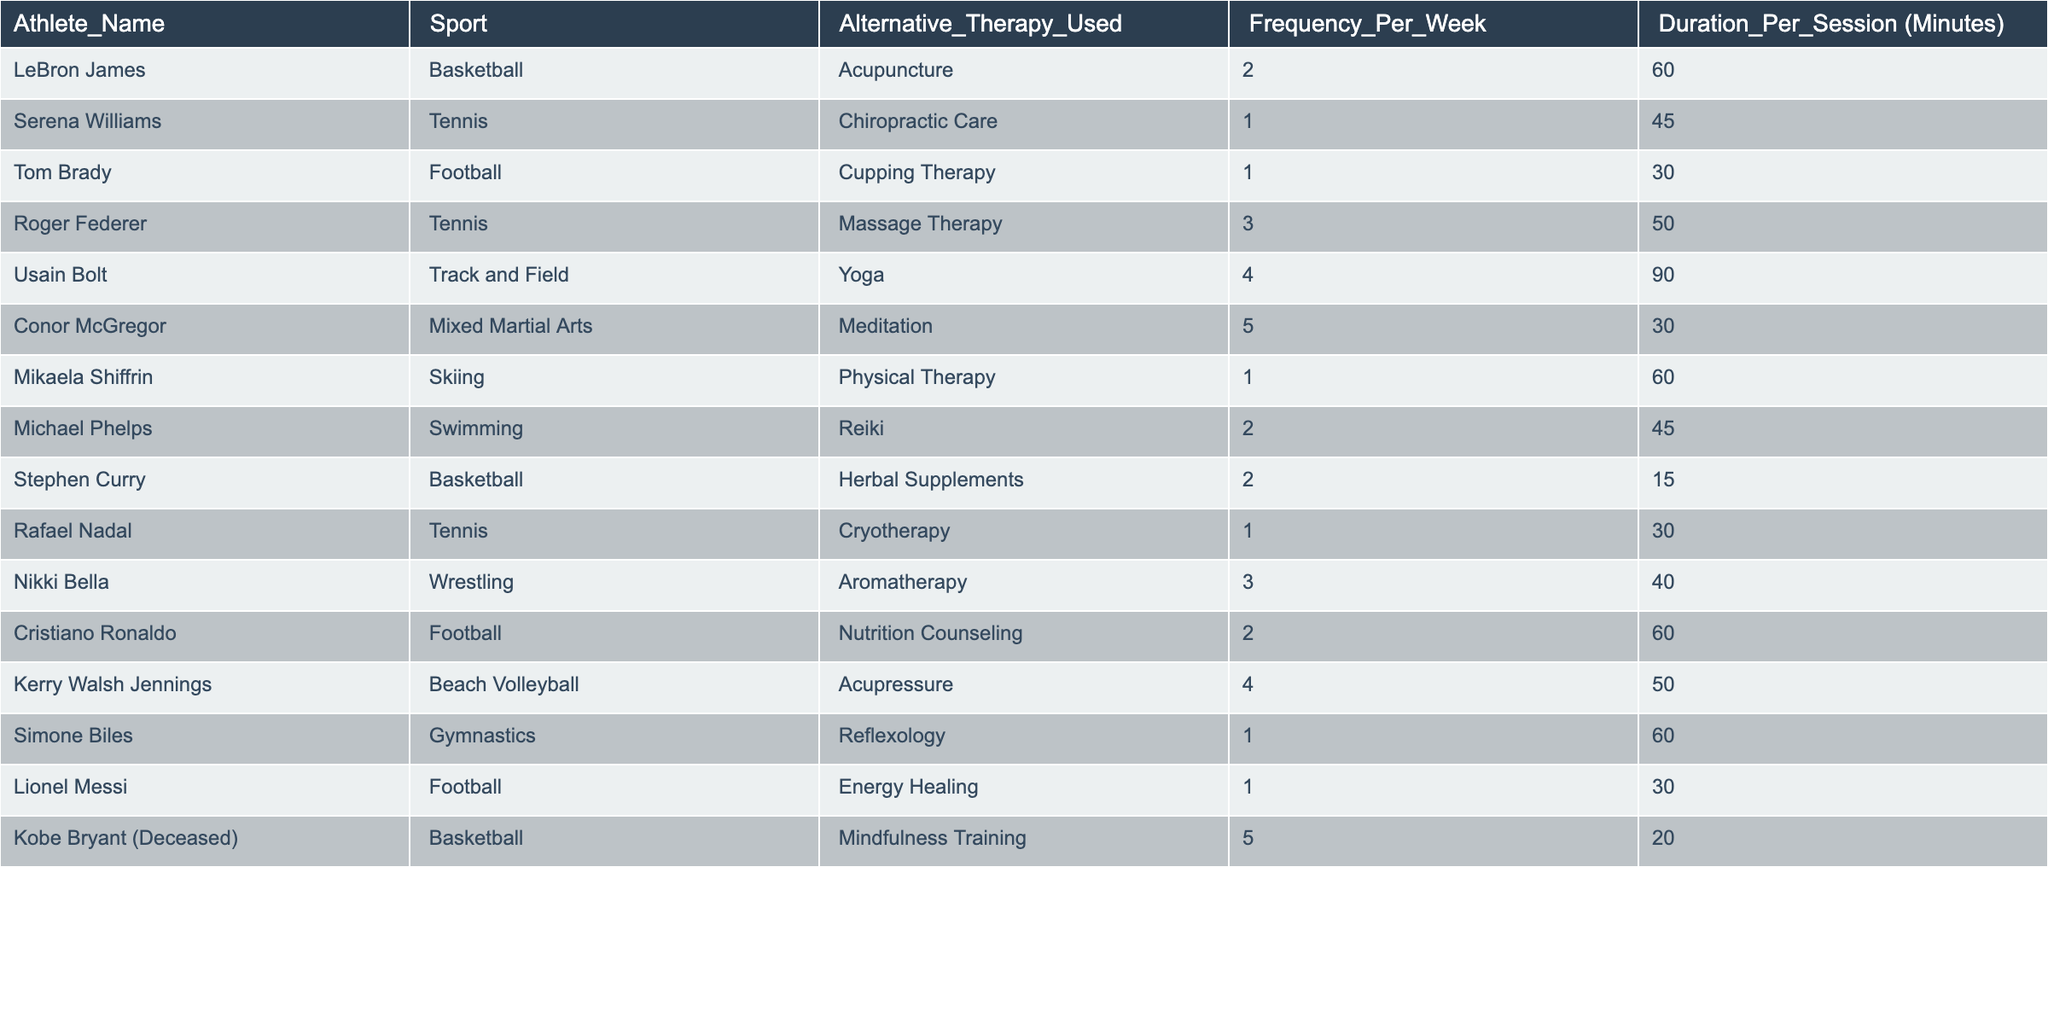What alternative therapy does Usain Bolt use? Referring to the table, Usain Bolt is listed under the "Athlete_Name" column, and the corresponding "Alternative_Therapy_Used" is "Yoga."
Answer: Yoga How many times per week does Conor McGregor practice meditation? Looking at the "Frequency_Per_Week" column for Conor McGregor, it shows he practices meditation 5 times per week.
Answer: 5 Which therapy has the longest session duration among the listed athletes? The "Duration_Per_Session" column indicates that Usain Bolt's Yoga session lasts 90 minutes, which is the highest value, showing it's the longest among all therapies listed.
Answer: 90 minutes What is the total weekly frequency of alternative therapies used by tennis players? We have two tennis players, Serena Williams (1 time) and Roger Federer (3 times), adding them gives us 1 + 3 = 4.
Answer: 4 Which athlete uses physical therapy, and what is their frequency per week? Mikaela Shiffrin is the athlete who uses "Physical Therapy," and the "Frequency_Per_Week" shows it is 1 time per week.
Answer: Mikaela Shiffrin, 1 time Is there any athlete who uses alternative therapy more than four times a week? Checking the "Frequency_Per_Week" values, the highest indicated is 5 times per week by Conor McGregor for meditation. Thus, there is an athlete who exceeds four times.
Answer: Yes What is the average frequency of alternative therapy usage among all athletes in the table? There are 15 data points; summing the frequencies (2 + 1 + 1 + 3 + 4 + 5 + 1 + 2 + 2 + 1 + 3 + 2 + 4 + 1 + 5) gives us 31, and dividing by 15 yields an average of 2.07, which rounds to approximately 2.1.
Answer: 2.1 How many athletes use Reiki as an alternative therapy? The table shows that only Michael Phelps uses Reiki, which is a single occurrence.
Answer: 1 What percentage of athletes listed use yoga as an alternative therapy? Out of 15 athletes, only Usain Bolt uses yoga, which means (1/15) * 100 = 6.67%, indicating a small proportion.
Answer: 6.67% Are there more athletes using therapies focused on physical well-being (e.g., massage, chiropractic care) than those using mental wellness therapies (e.g., meditation, mindfulness)? There are 5 athletes using physical therapies (Acupuncture, Chiropractic Care, Massage Therapy, Physical Therapy, Acupressure) and 2 using mental wellness therapies (Meditation, Mindfulness Training); hence, there is a greater number of athletes using physical therapies.
Answer: Yes 